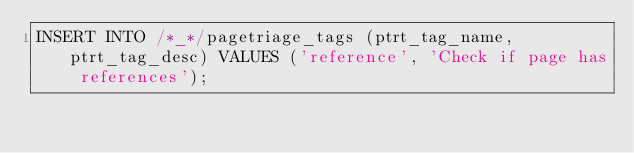<code> <loc_0><loc_0><loc_500><loc_500><_SQL_>INSERT INTO /*_*/pagetriage_tags (ptrt_tag_name, ptrt_tag_desc) VALUES ('reference', 'Check if page has references');
</code> 